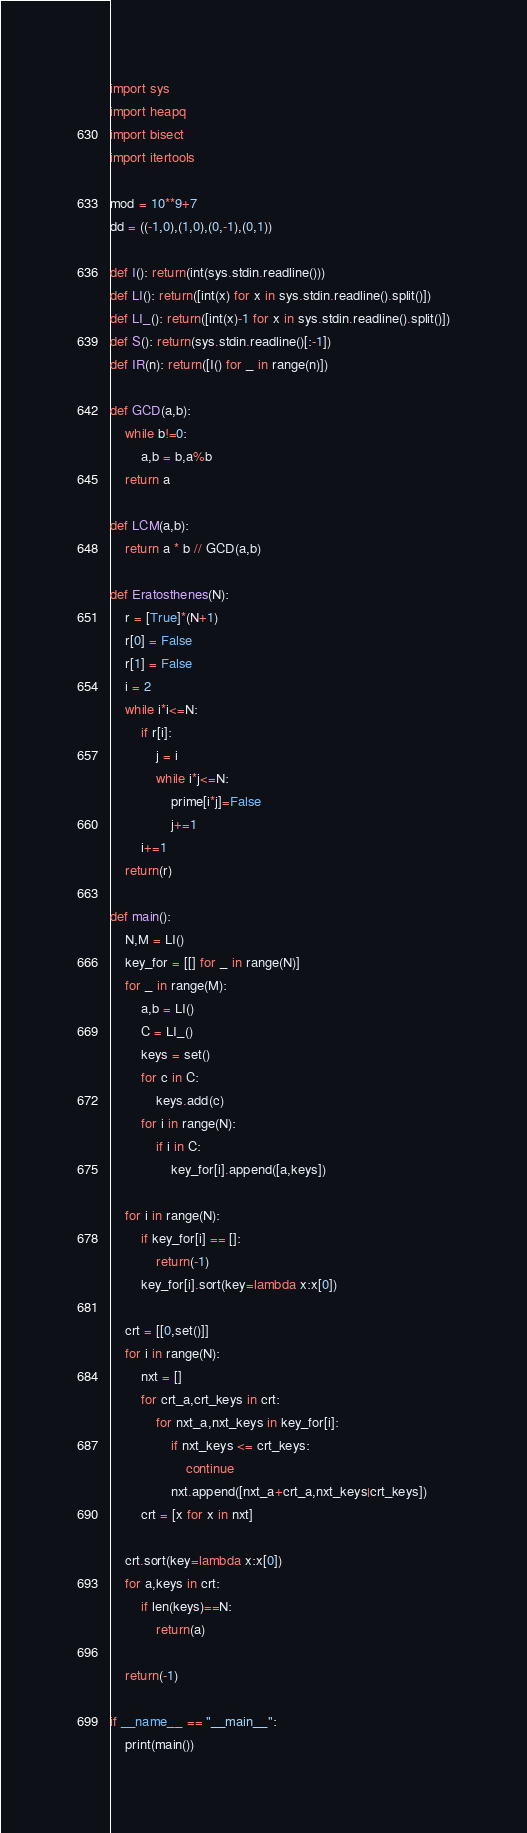Convert code to text. <code><loc_0><loc_0><loc_500><loc_500><_Python_>import sys
import heapq
import bisect
import itertools

mod = 10**9+7
dd = ((-1,0),(1,0),(0,-1),(0,1))

def I(): return(int(sys.stdin.readline()))
def LI(): return([int(x) for x in sys.stdin.readline().split()])
def LI_(): return([int(x)-1 for x in sys.stdin.readline().split()])
def S(): return(sys.stdin.readline()[:-1])
def IR(n): return([I() for _ in range(n)])

def GCD(a,b):
    while b!=0:
        a,b = b,a%b
    return a

def LCM(a,b):
    return a * b // GCD(a,b)

def Eratosthenes(N):
    r = [True]*(N+1)
    r[0] = False
    r[1] = False
    i = 2
    while i*i<=N:
        if r[i]: 
            j = i
            while i*j<=N:
                prime[i*j]=False
                j+=1
        i+=1
    return(r)

def main():
    N,M = LI()
    key_for = [[] for _ in range(N)]
    for _ in range(M):
        a,b = LI()
        C = LI_()
        keys = set()
        for c in C:
            keys.add(c)
        for i in range(N):
            if i in C:
                key_for[i].append([a,keys])

    for i in range(N):
        if key_for[i] == []:
            return(-1)
        key_for[i].sort(key=lambda x:x[0])

    crt = [[0,set()]]
    for i in range(N):
        nxt = []
        for crt_a,crt_keys in crt:
            for nxt_a,nxt_keys in key_for[i]:
                if nxt_keys <= crt_keys:
                    continue
                nxt.append([nxt_a+crt_a,nxt_keys|crt_keys])
        crt = [x for x in nxt]

    crt.sort(key=lambda x:x[0])
    for a,keys in crt:
        if len(keys)==N:
            return(a)

    return(-1)

if __name__ == "__main__":
    print(main())
</code> 